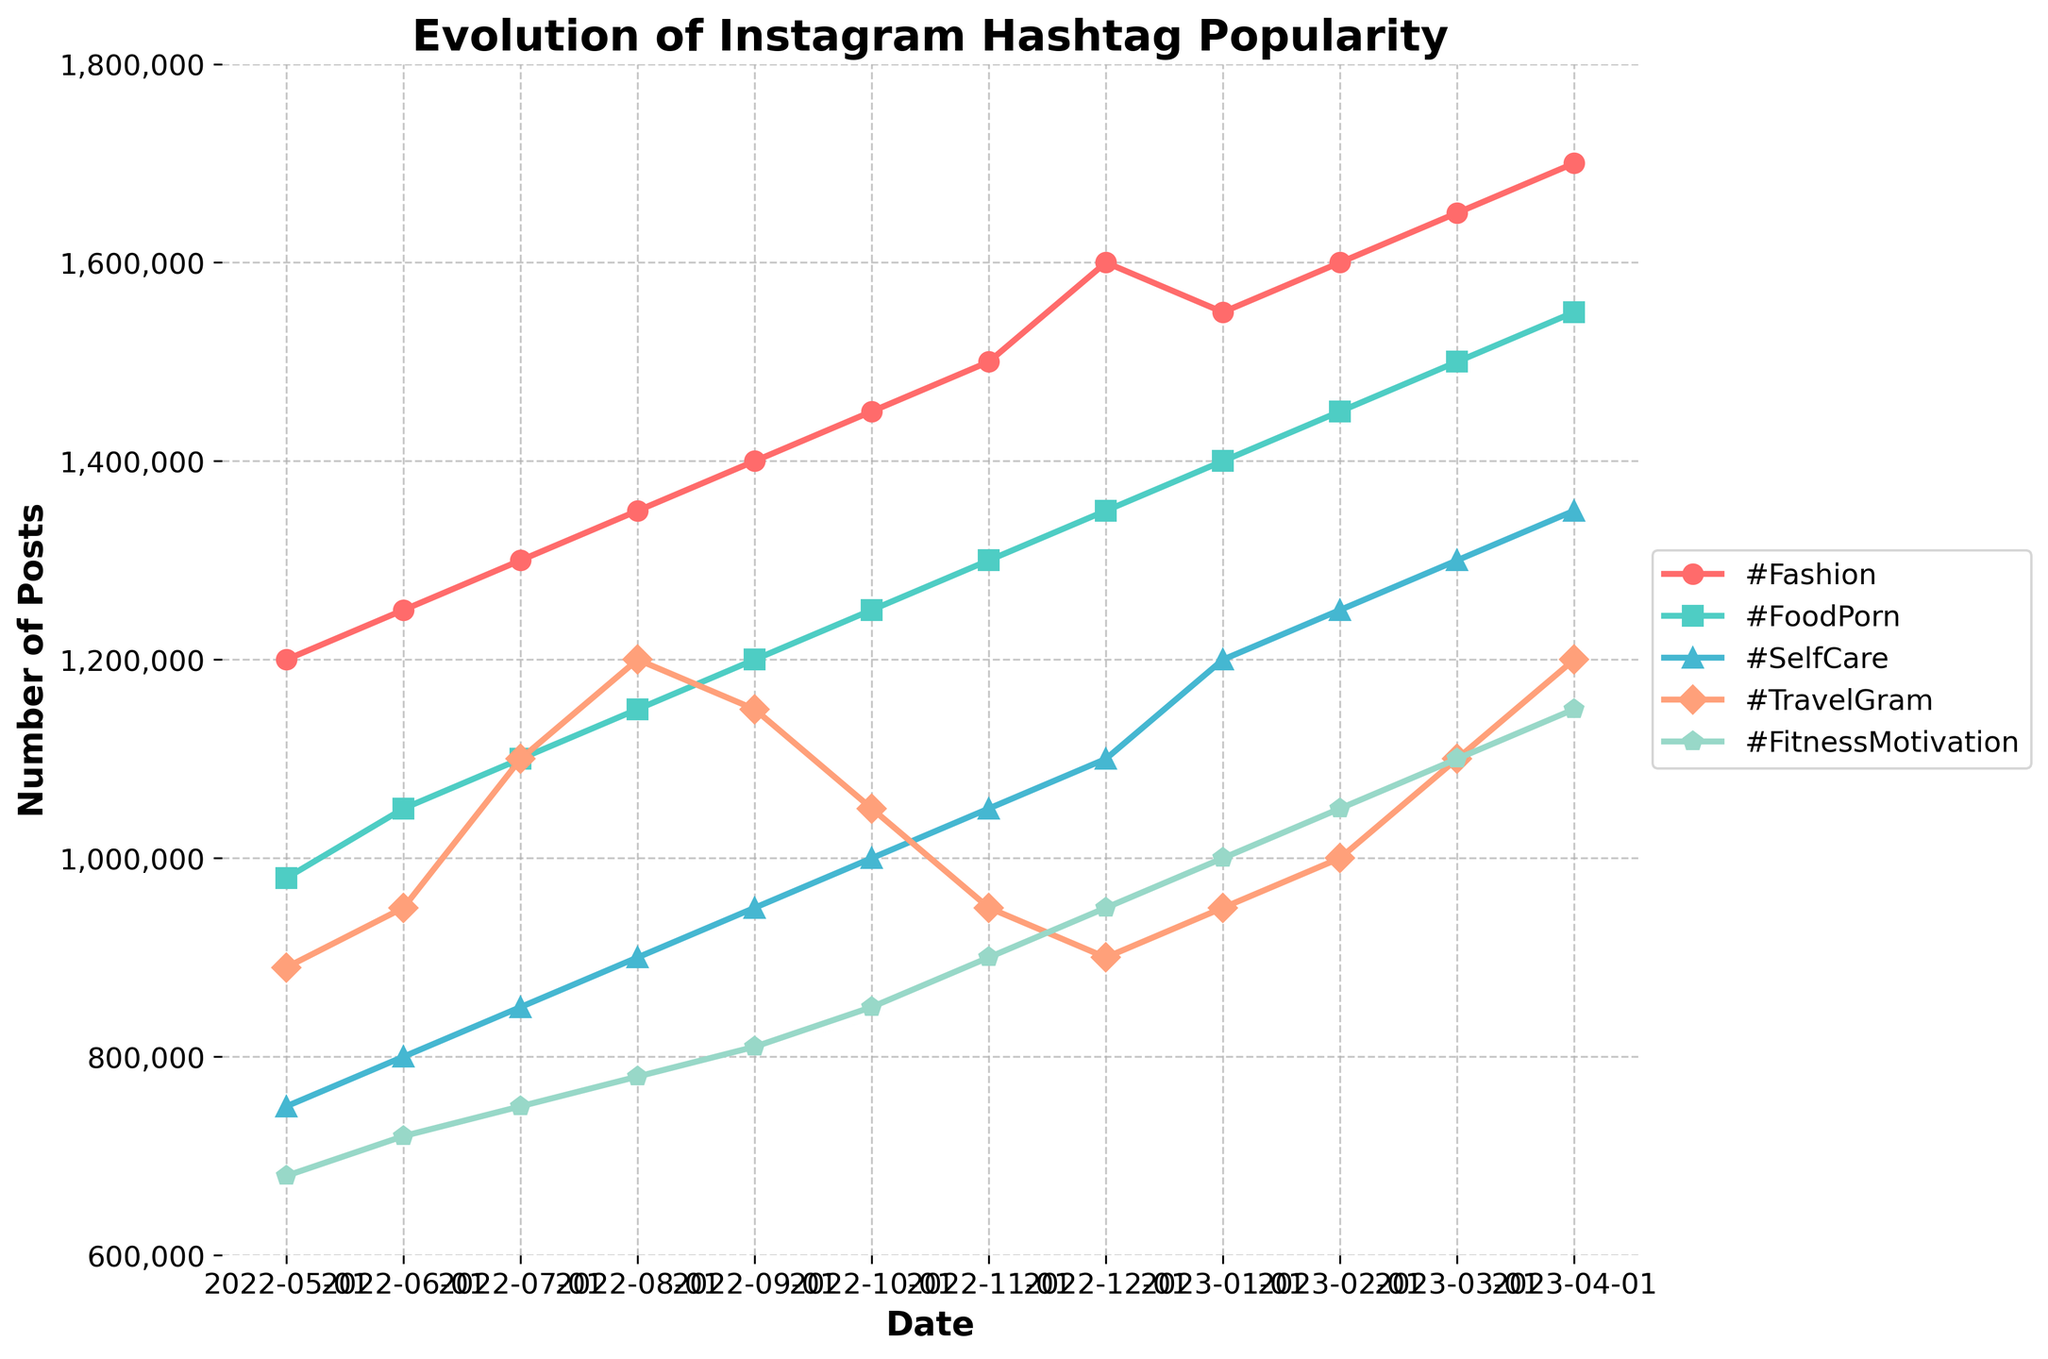How does the popularity of #TravelGram change from August 2022 to April 2023? To find out the change in popularity for #TravelGram, look at the data points for August 2022 and April 2023. In August 2022, the value is 1,200,000, and in April 2023, it is 1,200,000.
Answer: No change Which hashtag experienced the greatest growth in popularity over the past year? To determine this, calculate the difference between the highest and lowest values for each hashtag across the year. #Fashion increased from 1,200,000 to 1,700,000 (+500,000); #FoodPorn from 980,000 to 1,550,000 (+570,000); #SelfCare from 750,000 to 1,350,000 (+600,000); #TravelGram from 890,000 to 1,200,000 (+310,000); #FitnessMotivation from 680,000 to 1,150,000 (+470,000).
Answer: #SelfCare What is the average popularity of #FitnessMotivation over the past year? Sum all monthly values for #FitnessMotivation and divide by the number of months (12). (680,000 + 720,000 + 750,000 + 780,000 + 810,000 + 850,000 + 900,000 + 950,000 + 1,000,000 + 1,050,000 + 1,100,000 + 1,150,000) / 12 = 935,000
Answer: 935,000 Which hashtags had an equal number of posts in December 2022? Check the values for December 2022. #Fashion had 1,600,000, #FoodPorn had 1,350,000, #SelfCare had 1,100,000, #TravelGram had 900,000, and #FitnessMotivation had 950,000. No values are the same.
Answer: None During which month did #Fashion surpass 1,500,000 posts? Look at the data points for #Fashion. This surpasses 1,500,000 in November 2022, where it reached 1,500,000 posts.
Answer: November 2022 